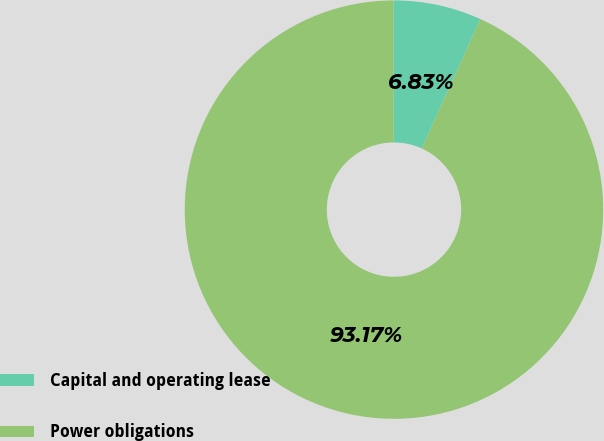Convert chart. <chart><loc_0><loc_0><loc_500><loc_500><pie_chart><fcel>Capital and operating lease<fcel>Power obligations<nl><fcel>6.83%<fcel>93.17%<nl></chart> 